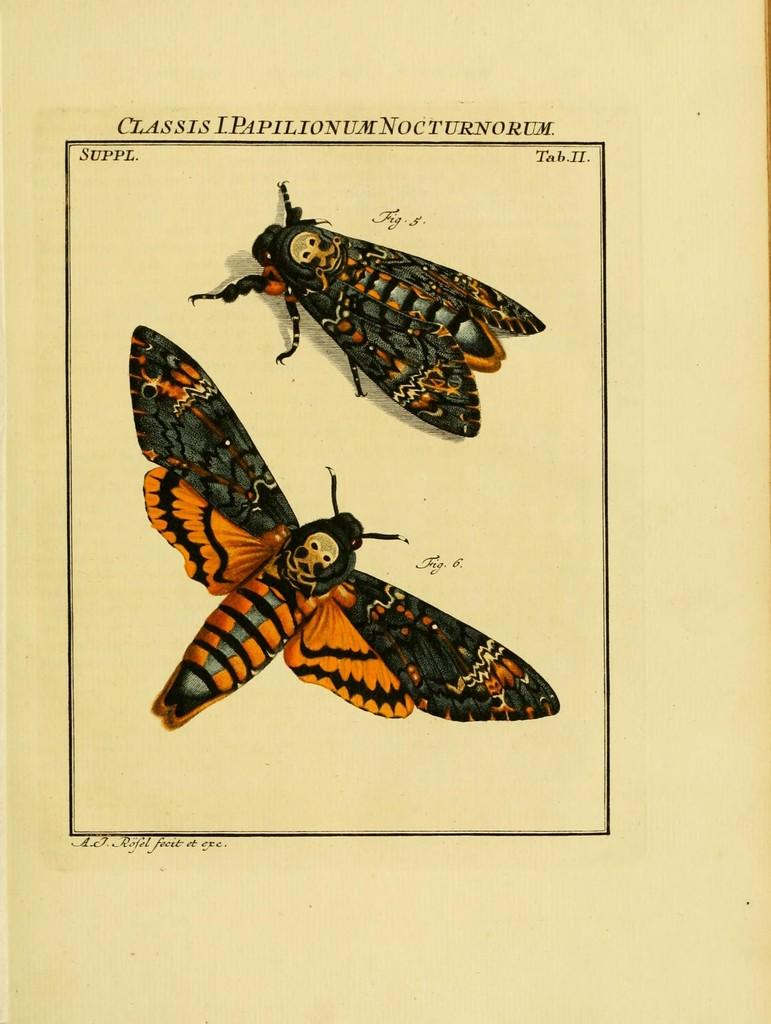What type of insect is in the image? There is a death's head hawkmoth in the image. Is there any text associated with the insect? Yes, there is text on the hawkmoth. What type of knife is the hawkmoth using to cut the stocking in the image? There is no knife or stocking present in the image; it only features a death's head hawkmoth with text on it. 